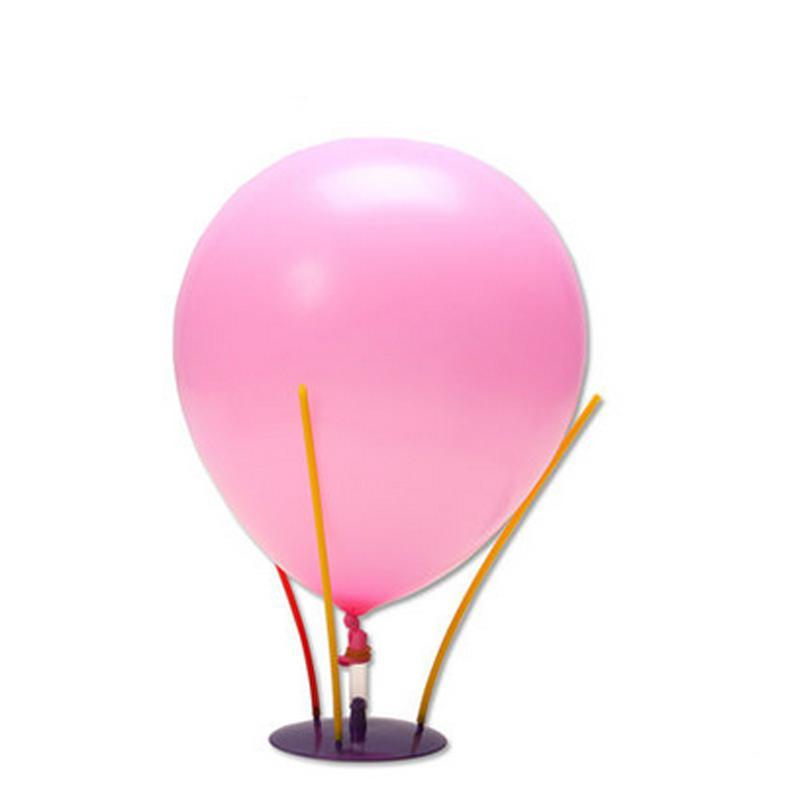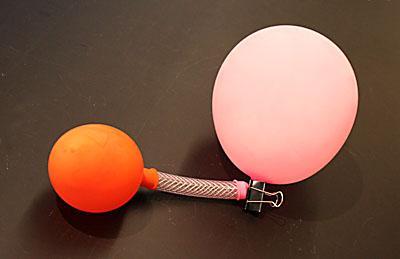The first image is the image on the left, the second image is the image on the right. Examine the images to the left and right. Is the description "A total of three balloons are shown, and one image contains only a pink-colored balloon." accurate? Answer yes or no. Yes. The first image is the image on the left, the second image is the image on the right. Considering the images on both sides, is "There are more balloons in the image on the right." valid? Answer yes or no. Yes. 